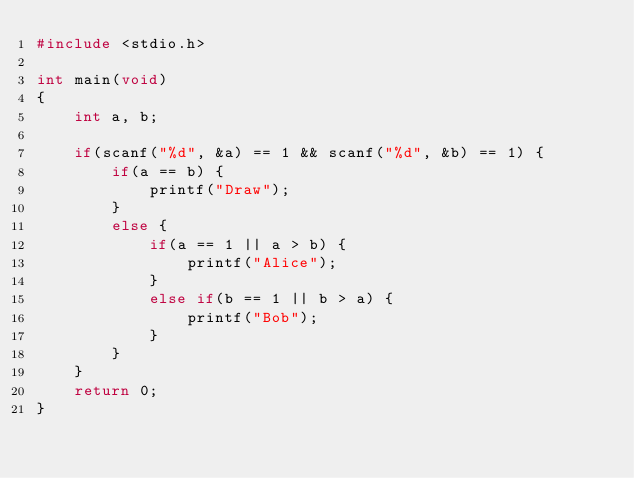<code> <loc_0><loc_0><loc_500><loc_500><_C_>#include <stdio.h>

int main(void)
{
	int a, b;
	
	if(scanf("%d", &a) == 1 && scanf("%d", &b) == 1) {
		if(a == b) {
			printf("Draw");
		}
		else {
			if(a == 1 || a > b) {
				printf("Alice");
			}
			else if(b == 1 || b > a) {
				printf("Bob");
			}
		}
	}
	return 0;
}</code> 